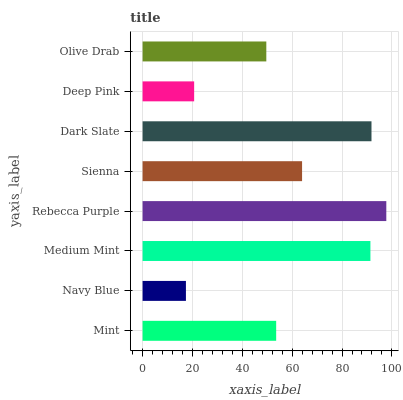Is Navy Blue the minimum?
Answer yes or no. Yes. Is Rebecca Purple the maximum?
Answer yes or no. Yes. Is Medium Mint the minimum?
Answer yes or no. No. Is Medium Mint the maximum?
Answer yes or no. No. Is Medium Mint greater than Navy Blue?
Answer yes or no. Yes. Is Navy Blue less than Medium Mint?
Answer yes or no. Yes. Is Navy Blue greater than Medium Mint?
Answer yes or no. No. Is Medium Mint less than Navy Blue?
Answer yes or no. No. Is Sienna the high median?
Answer yes or no. Yes. Is Mint the low median?
Answer yes or no. Yes. Is Dark Slate the high median?
Answer yes or no. No. Is Dark Slate the low median?
Answer yes or no. No. 